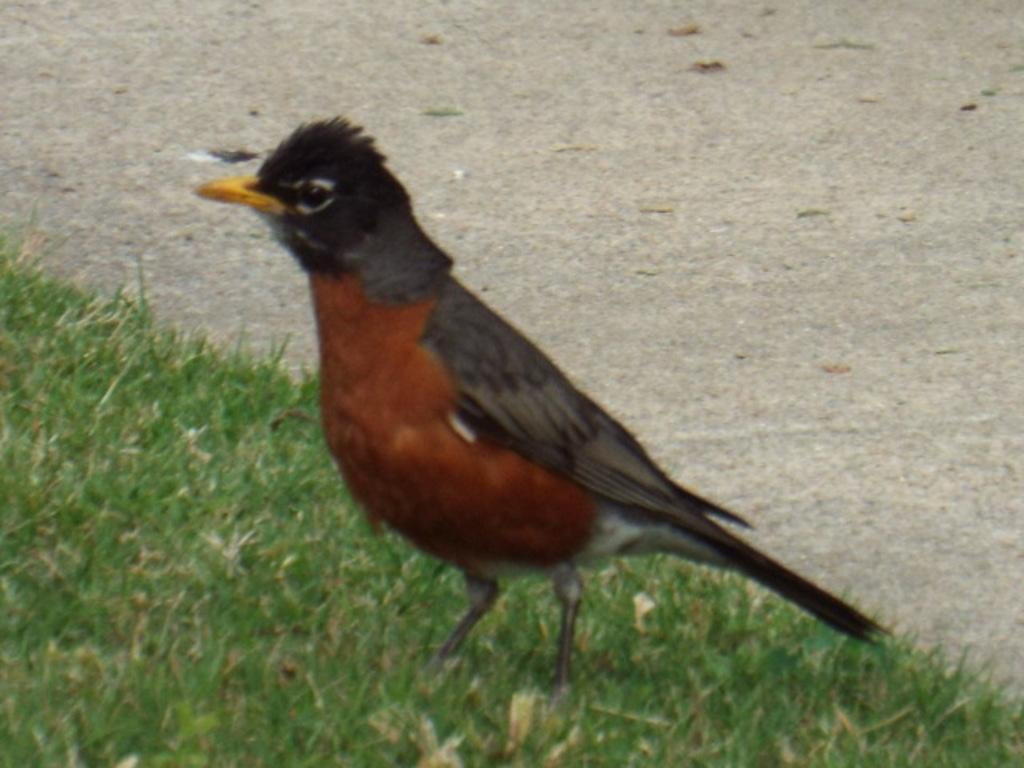Describe this image in one or two sentences. In this image we can see a bird on the ground. 